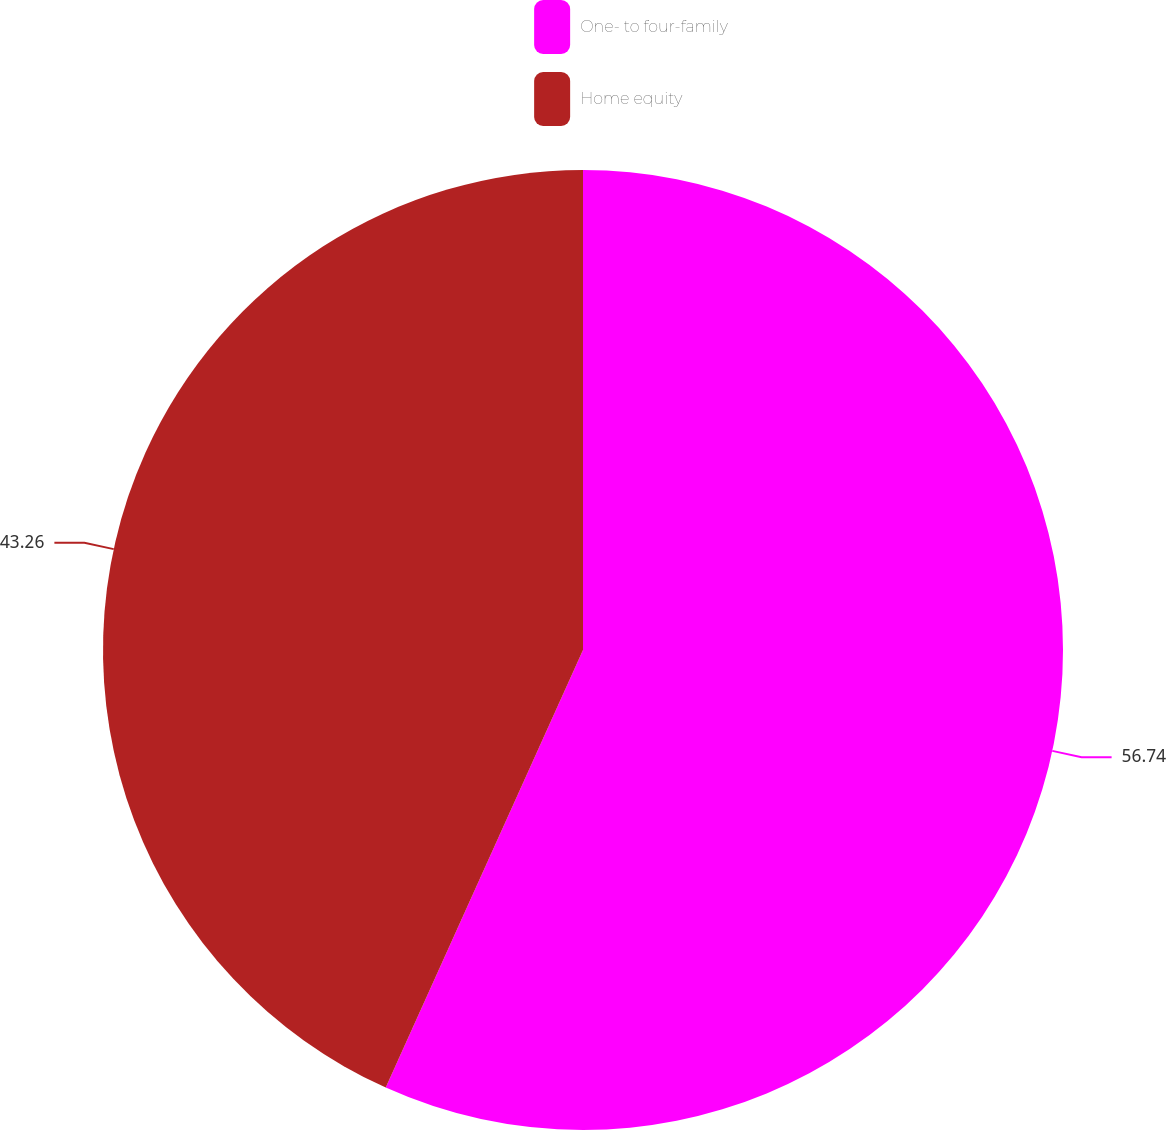<chart> <loc_0><loc_0><loc_500><loc_500><pie_chart><fcel>One- to four-family<fcel>Home equity<nl><fcel>56.74%<fcel>43.26%<nl></chart> 